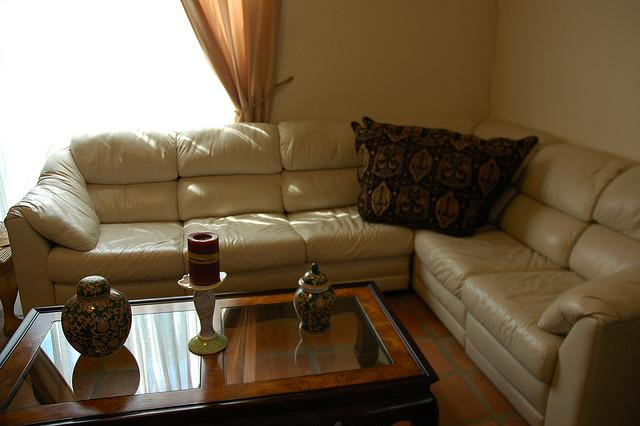Which item is most likely made from animal skin? Please explain your reasoning. couch. It is leather 